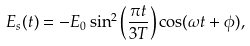<formula> <loc_0><loc_0><loc_500><loc_500>E _ { s } ( t ) = - E _ { 0 } \sin ^ { 2 } \left ( \frac { \pi t } { 3 T } \right ) \cos ( \omega t + \phi ) ,</formula> 